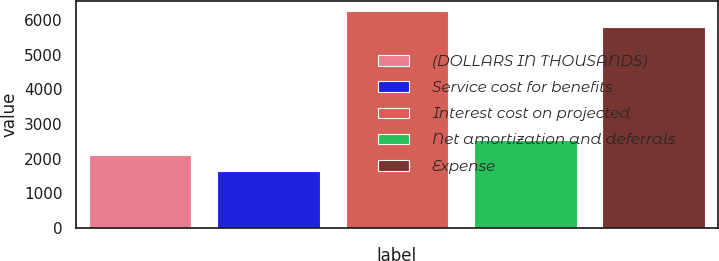Convert chart to OTSL. <chart><loc_0><loc_0><loc_500><loc_500><bar_chart><fcel>(DOLLARS IN THOUSANDS)<fcel>Service cost for benefits<fcel>Interest cost on projected<fcel>Net amortization and deferrals<fcel>Expense<nl><fcel>2096.2<fcel>1644<fcel>6250.2<fcel>2548.4<fcel>5798<nl></chart> 